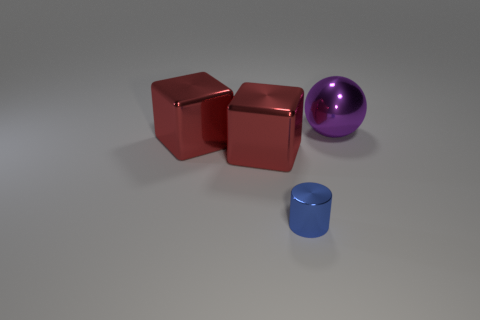Add 4 spheres. How many objects exist? 8 Subtract 0 gray spheres. How many objects are left? 4 Subtract all spheres. How many objects are left? 3 Subtract all small green metal cylinders. Subtract all blue metal cylinders. How many objects are left? 3 Add 1 small metal cylinders. How many small metal cylinders are left? 2 Add 2 green cubes. How many green cubes exist? 2 